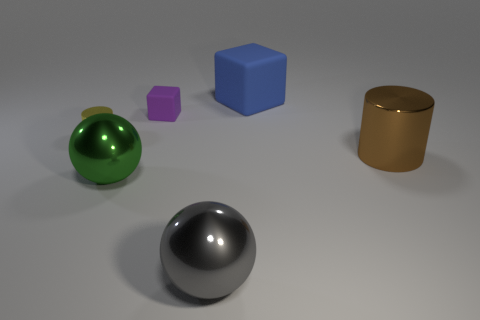What shape is the large brown thing that is made of the same material as the green sphere?
Give a very brief answer. Cylinder. There is a cylinder that is on the left side of the shiny object that is to the right of the blue thing; what is its size?
Provide a succinct answer. Small. What is the shape of the big green metallic thing?
Provide a short and direct response. Sphere. How many small things are either red matte blocks or brown metallic objects?
Keep it short and to the point. 0. There is another purple object that is the same shape as the big rubber thing; what is its size?
Your answer should be very brief. Small. What number of things are both on the right side of the green thing and behind the green object?
Keep it short and to the point. 3. Is the shape of the gray shiny thing the same as the thing that is behind the small purple rubber cube?
Make the answer very short. No. Are there more big green spheres that are in front of the big green metal object than brown cylinders?
Your answer should be very brief. No. Are there fewer yellow shiny things to the right of the yellow shiny cylinder than big blue matte cylinders?
Your answer should be very brief. No. What number of tiny shiny cylinders are the same color as the tiny block?
Your response must be concise. 0. 